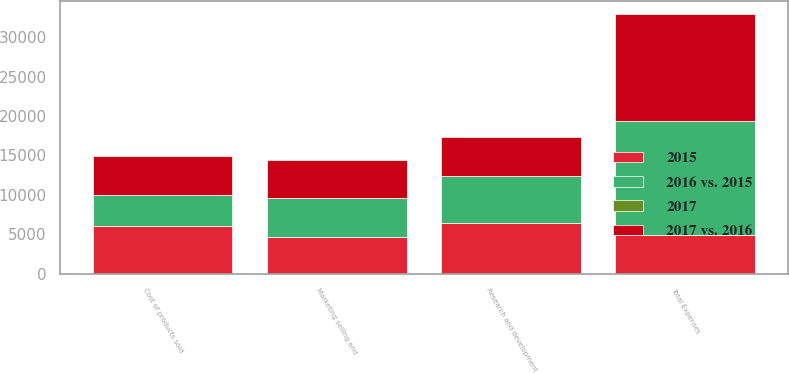Convert chart. <chart><loc_0><loc_0><loc_500><loc_500><stacked_bar_chart><ecel><fcel>Cost of products sold<fcel>Marketing selling and<fcel>Research and development<fcel>Total Expenses<nl><fcel>2015<fcel>6066<fcel>4687<fcel>6411<fcel>4911<nl><fcel>2017 vs. 2016<fcel>4946<fcel>4911<fcel>4940<fcel>13512<nl><fcel>2016 vs. 2015<fcel>3909<fcel>4841<fcel>5920<fcel>14483<nl><fcel>2017<fcel>23<fcel>5<fcel>30<fcel>16<nl></chart> 